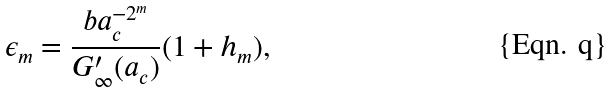Convert formula to latex. <formula><loc_0><loc_0><loc_500><loc_500>\epsilon _ { m } = \frac { b a _ { c } ^ { - 2 ^ { m } } } { G ^ { \prime } _ { \infty } ( a _ { c } ) } ( 1 + h _ { m } ) ,</formula> 